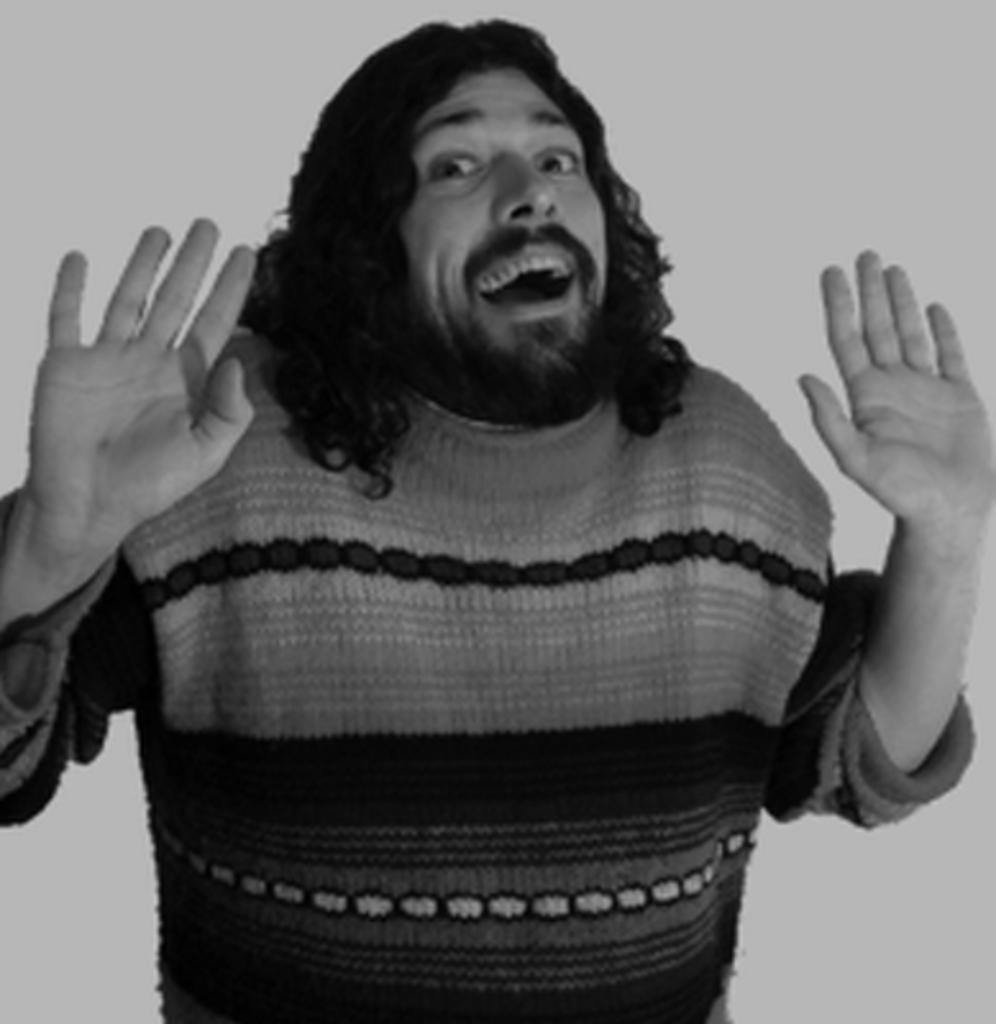What is the main subject of the image? There is a person standing in the middle of the image. What can be seen in the background of the image? The background of the image is white. What type of celery is being smoked through a pipe in the image? There is no celery or pipe present in the image; it only features a person standing in the middle and a white background. 